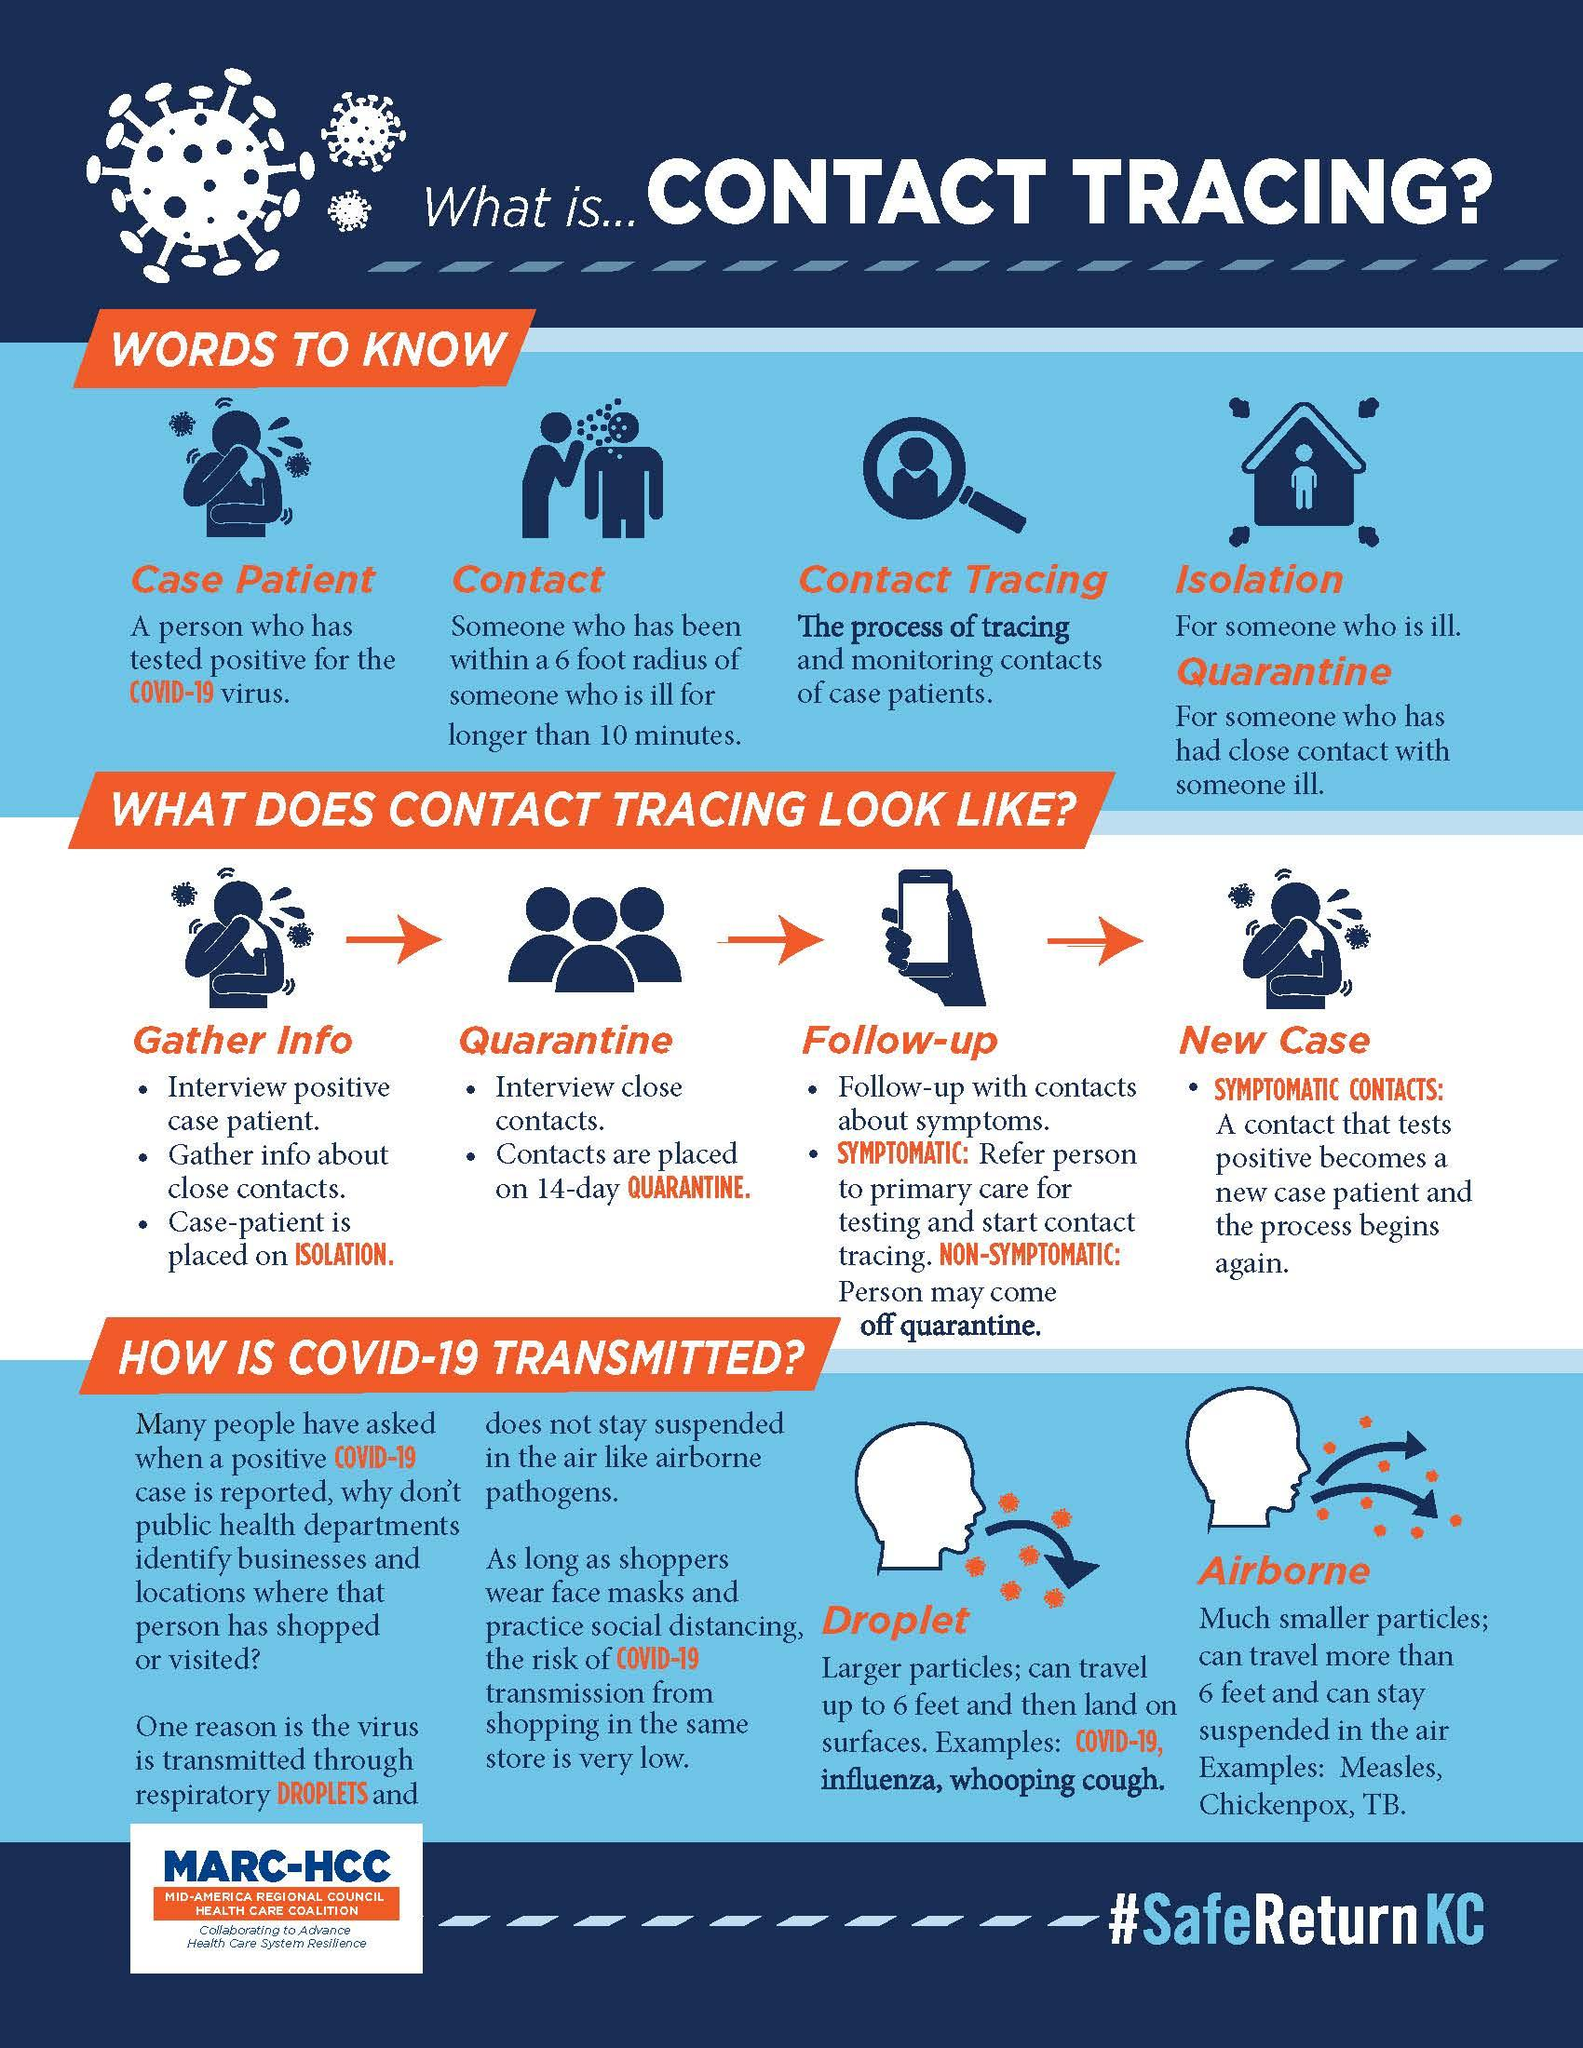Indicate a few pertinent items in this graphic. The droplets transmitting diseases include Covid-19, influenza, and whooping cough. There are several airborne diseases, including measles, chickenpox, and tuberculosis. There are two types of symptoms. COVID-19 can be transmitted through two methods: respiratory droplets that are produced when an infected person talks, coughs, or sneezes, and close contact with an infected person. Under the heading "Quarantine," there are a total of 2 steps. 